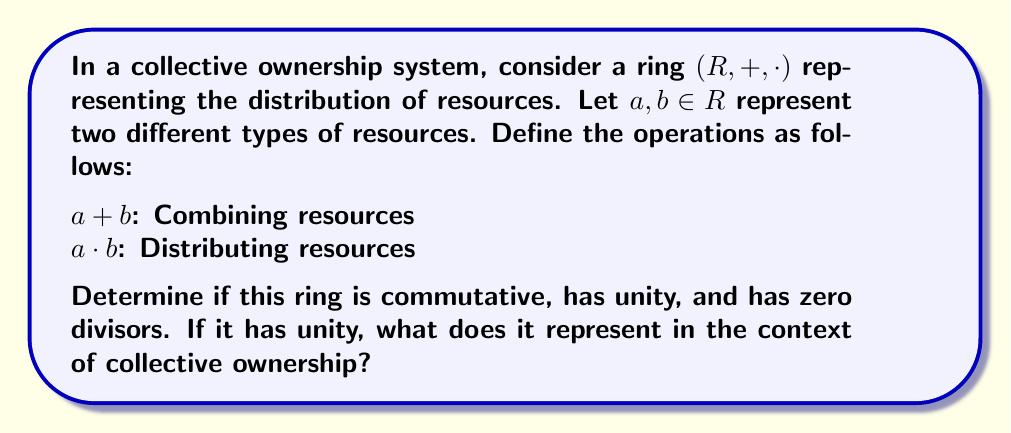Help me with this question. Let's examine each property of the ring $(R, +, \cdot)$ in the context of collective ownership:

1. Commutativity:
For addition: $a + b = b + a$ (Combining resources $a$ and $b$ is the same as combining $b$ and $a$)
For multiplication: $a \cdot b = b \cdot a$ (Distributing resource $a$ to $b$ is the same as distributing $b$ to $a$)

Both operations are commutative, reflecting the equality in resource distribution and combination in a collective system.

2. Unity:
The ring has unity if there exists an element $e \in R$ such that $a \cdot e = e \cdot a = a$ for all $a \in R$.
In the context of collective ownership, unity would represent a neutral resource that, when distributed, doesn't change the original resource. This could be interpreted as the collective's baseline state or the absence of additional distribution.

3. Zero divisors:
Zero divisors exist if there are non-zero elements $a, b \in R$ such that $a \cdot b = 0$.
In this system, zero divisors would represent resources that, when distributed together, result in no net resource (perhaps due to cancellation or complete consumption).

To determine if zero divisors exist, we'd need more information about the specific resource system. However, in many practical collective ownership systems, zero divisors could exist. For example, if $a$ represents labor and $b$ represents raw materials, $a \cdot b = 0$ could represent a situation where all raw materials are consumed in the production process.

The unity in this ring, if it exists, would represent the state of the collective where distributing this "resource" doesn't change the existing resources. This could be interpreted as the collective's status quo or baseline state.
Answer: The ring $(R, +, \cdot)$ representing resource distribution in a collective ownership system is commutative for both addition and multiplication. It likely has unity, representing the collective's baseline state. The existence of zero divisors depends on the specific resource system, but they are possible in many practical scenarios. The unity, if it exists, represents a neutral state of resource distribution that maintains the status quo of the collective. 